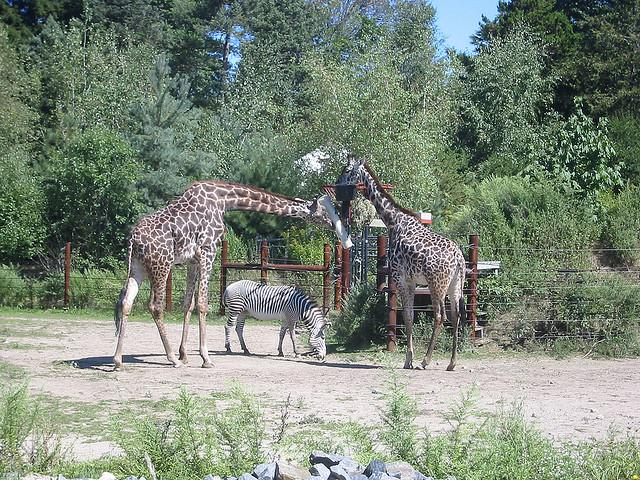What animal is between the giraffes? zebra 